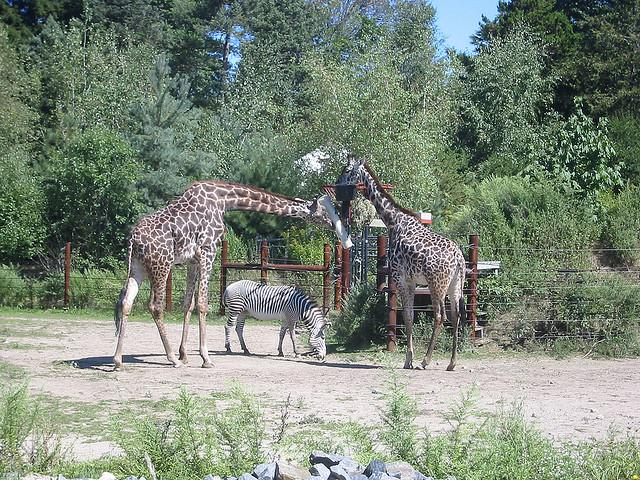What animal is between the giraffes? zebra 